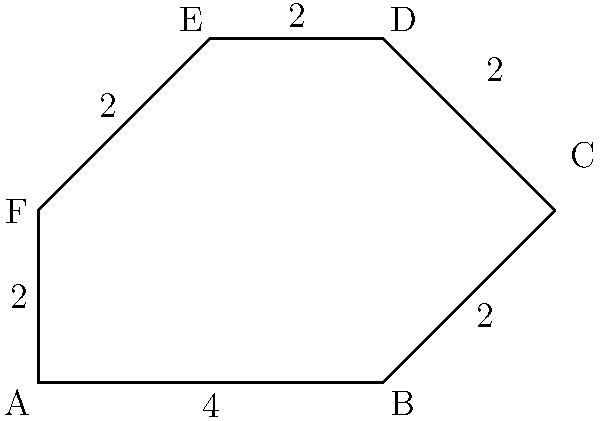You've designed a new hexagon-shaped game board for your puzzle game. The board has irregular sides as shown in the diagram. If the bottom side of the hexagon is 4 units long and all other sides are 2 units long, what is the perimeter of the game board? Let's approach this step-by-step:

1) First, let's identify what we know:
   - The bottom side (AB) is 4 units long
   - All other sides (BC, CD, DE, EF, and FA) are 2 units long

2) To find the perimeter, we need to add up the lengths of all sides:

   Perimeter = AB + BC + CD + DE + EF + FA

3) Let's substitute the known values:

   Perimeter = 4 + 2 + 2 + 2 + 2 + 2

4) Now, let's add these numbers:

   Perimeter = 4 + (5 × 2) = 4 + 10 = 14

Therefore, the perimeter of the hexagon-shaped game board is 14 units.
Answer: 14 units 